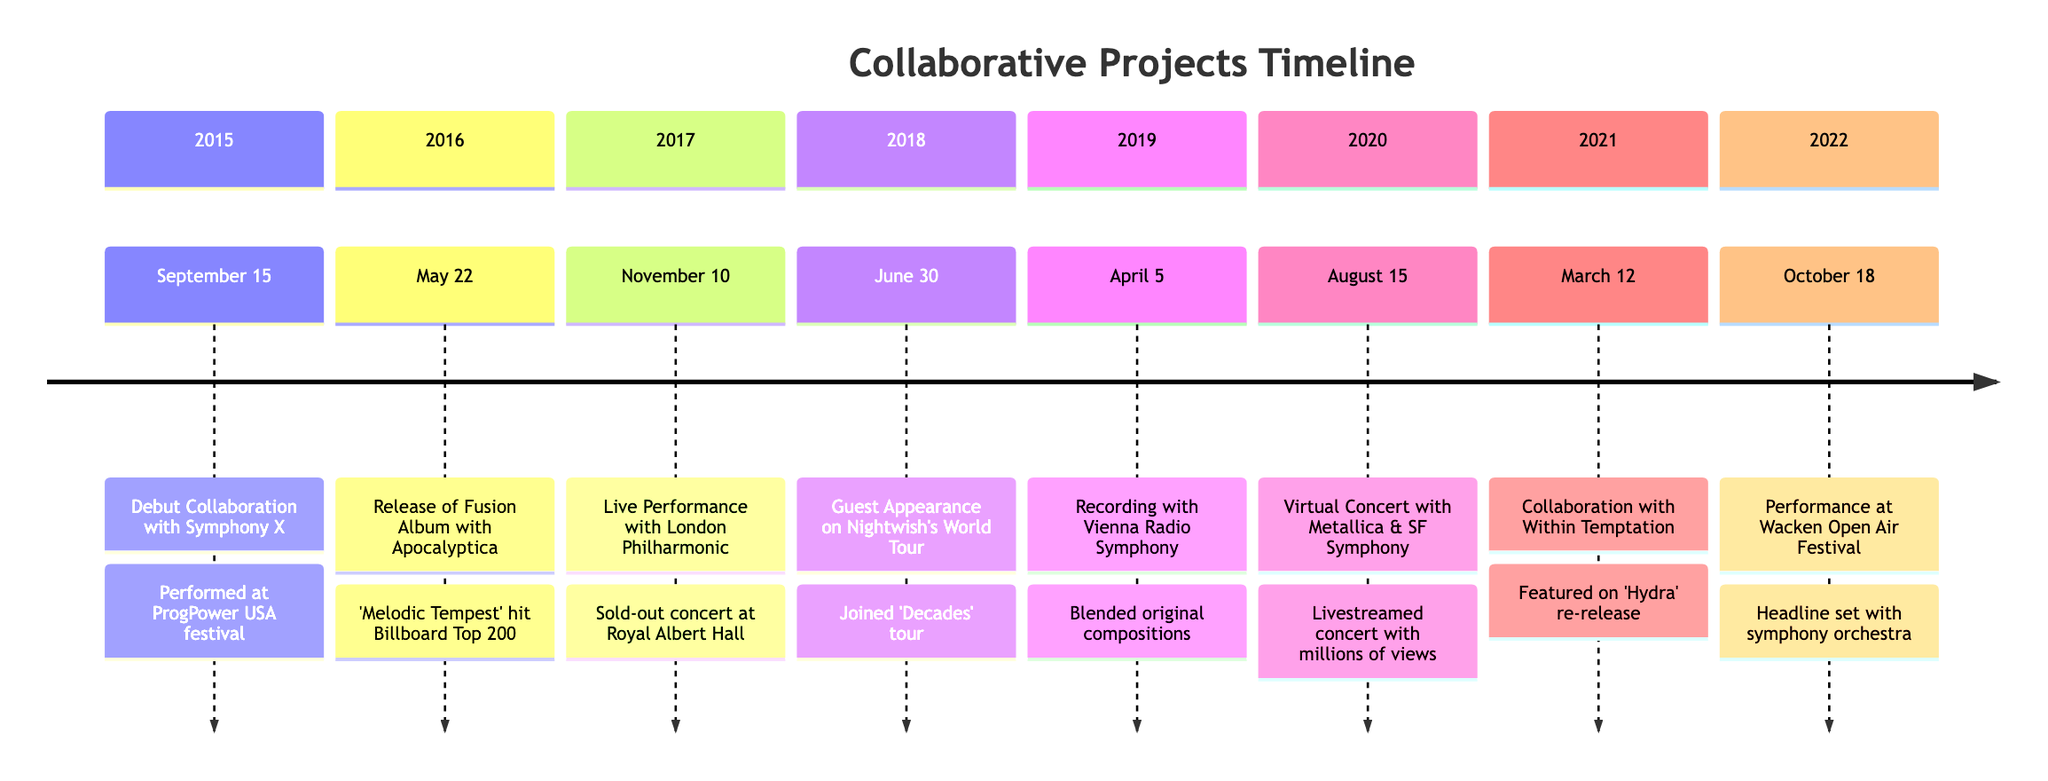What was the first event on the timeline? The timeline begins in September 2015, with the debut collaboration with Symphony X. This is the first listed event on the timeline, making it the starting point for all subsequent entries.
Answer: Debut Collaboration with Symphony X How many total collaborative projects are listed? By counting all the entries in the timeline, we see there are eight individual events listed, representing unique collaborative projects.
Answer: 8 What was the outcome of the performance on November 10, 2017? On this date, the live performance with the London Philharmonic Orchestra was conducted at the Royal Albert Hall, resulting in a sold-out concert. This outcome clearly states the success of that event.
Answer: Sold-out concert at Royal Albert Hall Which collaborative project marked a significant event in 2020? In 2020, the virtual concert with Metallica and the San Francisco Symphony stands out. This was particularly significant due to the COVID-19 pandemic, which forced the concert to be livestreamed.
Answer: Virtual Concert with Metallica & SF Symphony What was the main genre focus in the collaboration with Apocalyptica? The collaboration with Apocalyptica centered on the fusion of operatic vocals with symphonic metal cello compositions, which is a distinct merging of genres.
Answer: Symphonic metal cello compositions What key outcome was achieved through the collaboration with Within Temptation? The collaboration resulted in a special edition re-release of 'Hydra', where operatic elements were skillfully blended into a track, showing the intersection of both performance styles.
Answer: Featured on 'Hydra' re-release Which project involved a performance at a renowned festival? The performance at Wacken Open Air Festival involved a headline set that integrated a symphony orchestra live, highlighting the strong connection between metal and opera in a festival setting.
Answer: Performance at Wacken Open Air Festival What date corresponds to the release of the fusion album with Apocalyptica? The release of the fusion album with Apocalyptica, titled 'Melodic Tempest', occurred on May 22, 2016, marking an important point in the timeline for the blended music genre.
Answer: May 22, 2016 What was the notable venue for the performance on June 30, 2018? The notable venue for the guest appearance on Nightwish's World Tour was during their 'Decades' tour, captivating audiences worldwide, but the exact venue is not mentioned.
Answer: (No specific venue mentioned) 